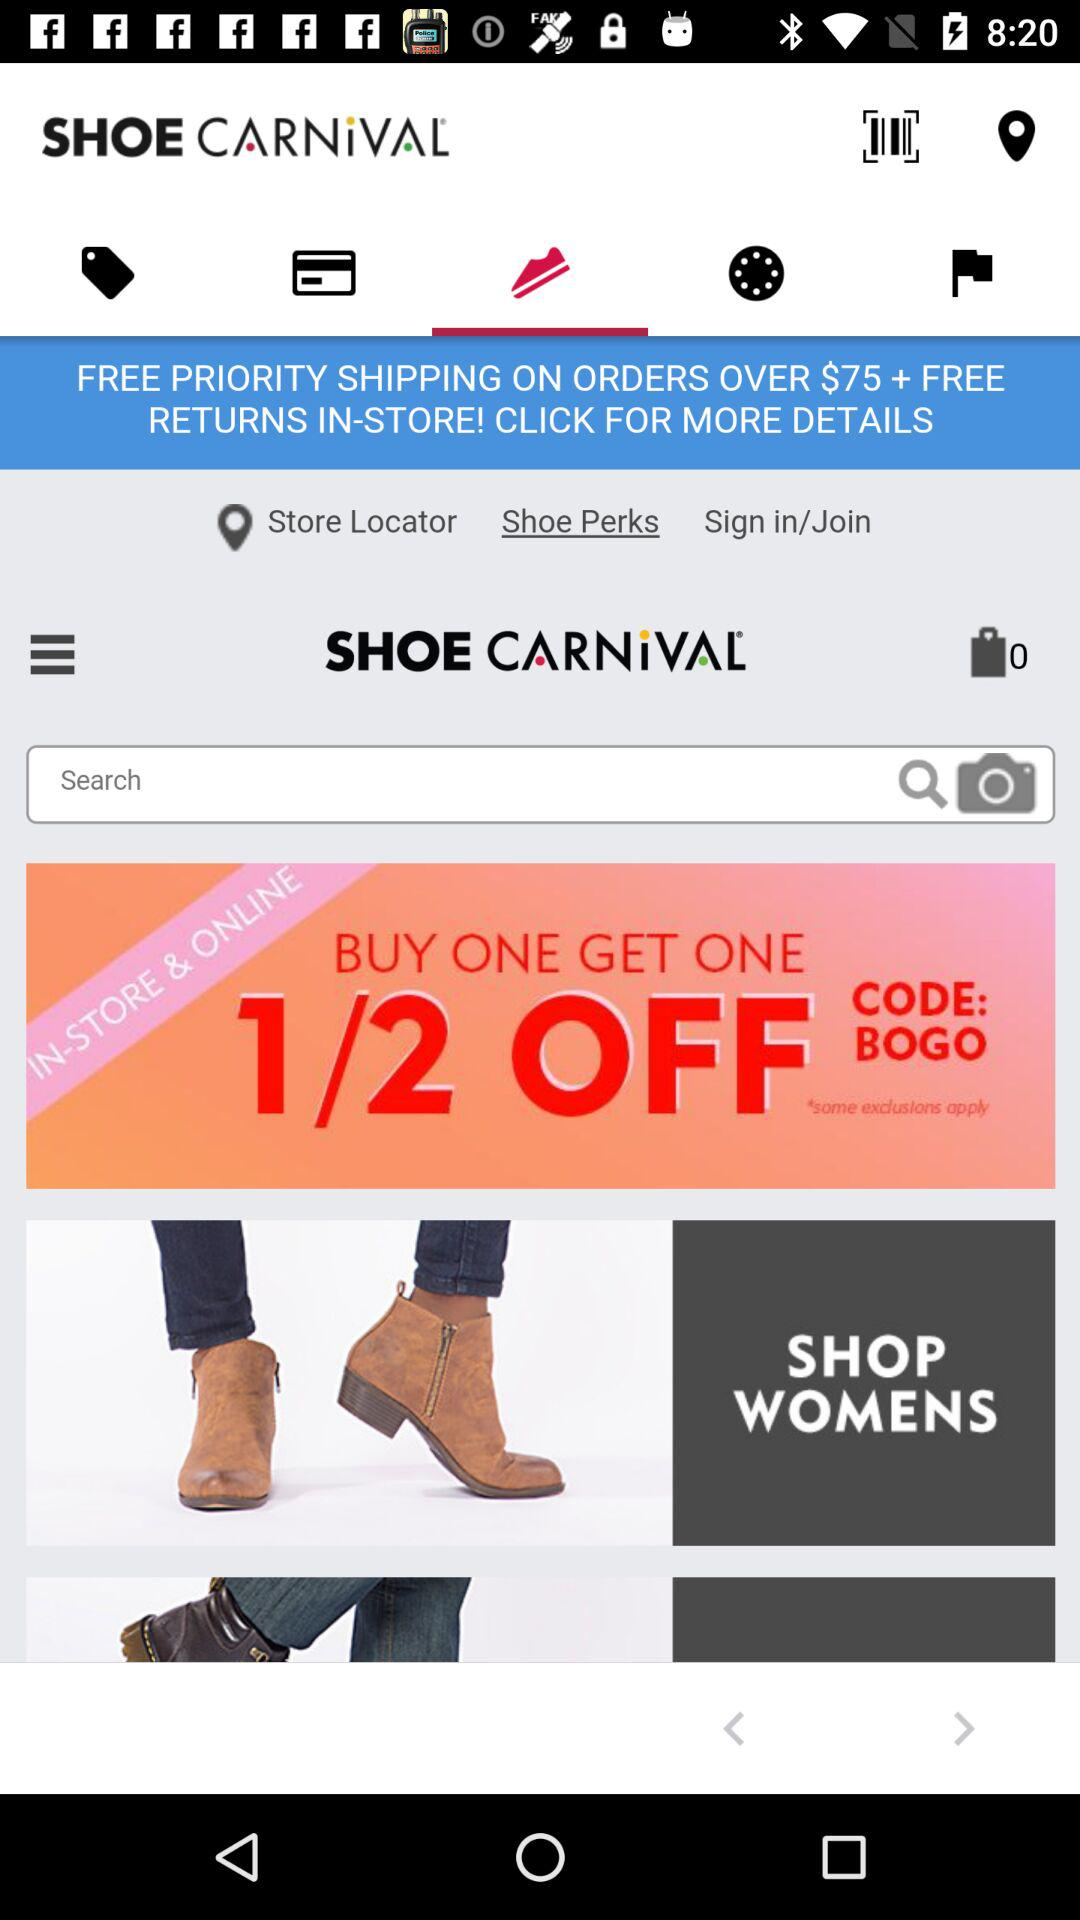What's the code? The code is "BOGO". 